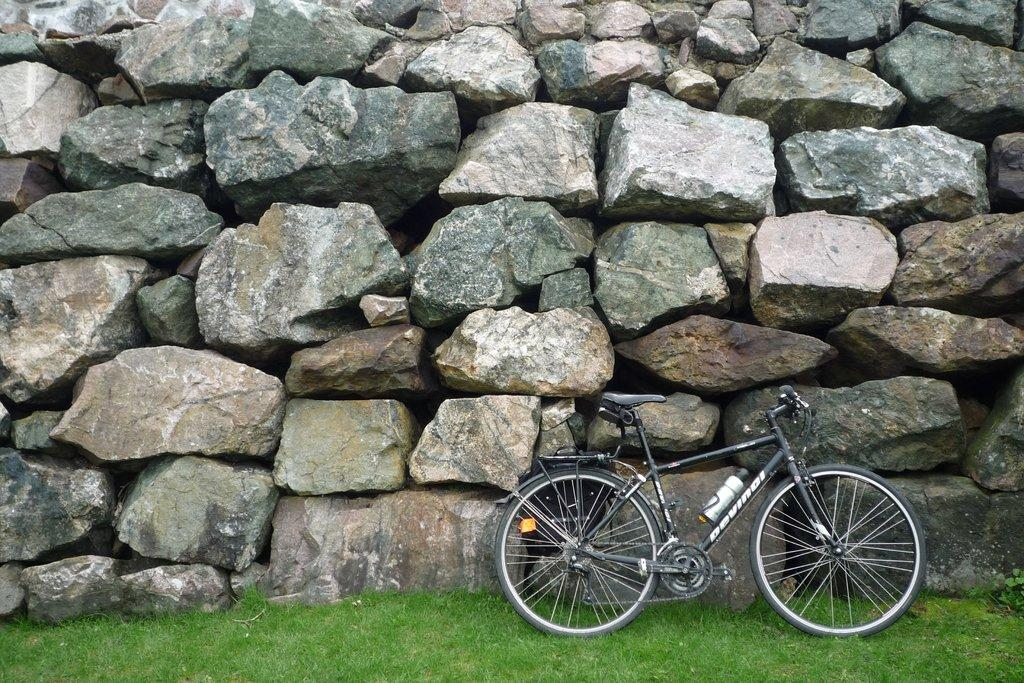What type of structure is visible in the image? There is a rock wall in the image. What mode of transportation can be seen in the image? There is a bicycle in the image. What object is present that might contain a liquid? There is a bottle in the image. What type of terrain is visible in the image? There is grassy land in the image. What type of rice is being cooked in the image? There is no rice present in the image. What list is being referenced in the image? There is no list present in the image. 